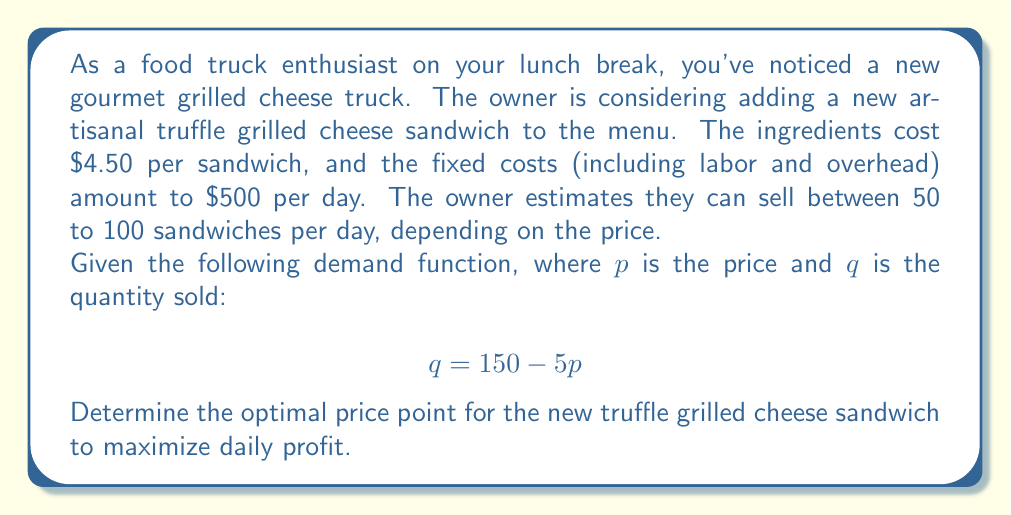Can you answer this question? Let's approach this step-by-step:

1) First, we need to set up our profit function. Profit is revenue minus costs:

   $$ \text{Profit} = \text{Revenue} - \text{Variable Costs} - \text{Fixed Costs} $$

2) Revenue is price times quantity: $pq$
   Variable costs are $4.50 per sandwich: $4.50q$
   Fixed costs are $500

   So our profit function is:

   $$ \text{Profit} = pq - 4.50q - 500 $$

3) We know that $q = 150 - 5p$, so let's substitute this into our profit function:

   $$ \text{Profit} = p(150-5p) - 4.50(150-5p) - 500 $$

4) Expand this:

   $$ \text{Profit} = 150p - 5p^2 - 675 + 22.5p - 500 $$
   $$ \text{Profit} = -5p^2 + 172.5p - 1175 $$

5) To find the maximum profit, we need to find where the derivative of this function equals zero:

   $$ \frac{d(\text{Profit})}{dp} = -10p + 172.5 = 0 $$

6) Solve this equation:

   $$ -10p + 172.5 = 0 $$
   $$ -10p = -172.5 $$
   $$ p = 17.25 $$

7) To confirm this is a maximum (not a minimum), we can check that the second derivative is negative:

   $$ \frac{d^2(\text{Profit})}{dp^2} = -10 $$

   Which is indeed negative.

8) Therefore, the optimal price is $17.25.

9) We should check if this falls within our feasible range:

   At $p = 17.25$, $q = 150 - 5(17.25) = 63.75$

   This is between 50 and 100, so it's within our feasible range.
Answer: The optimal price point for the new truffle grilled cheese sandwich to maximize daily profit is $17.25. 